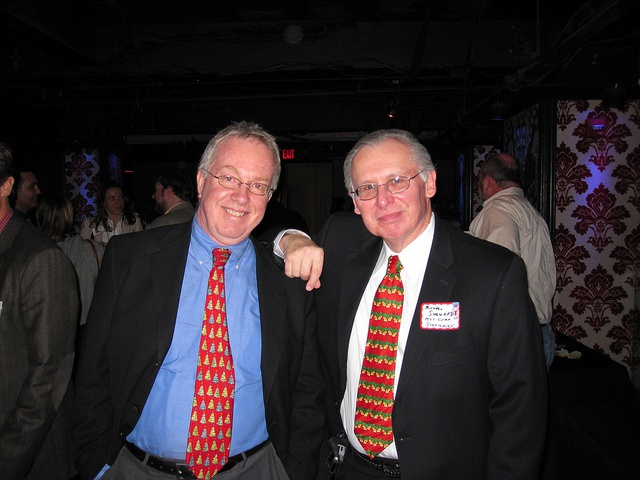Describe the objects in this image and their specific colors. I can see people in black, white, salmon, and brown tones, people in black, gray, lightblue, and salmon tones, people in black, maroon, and brown tones, people in black, gray, and maroon tones, and tie in black, brown, and tan tones in this image. 